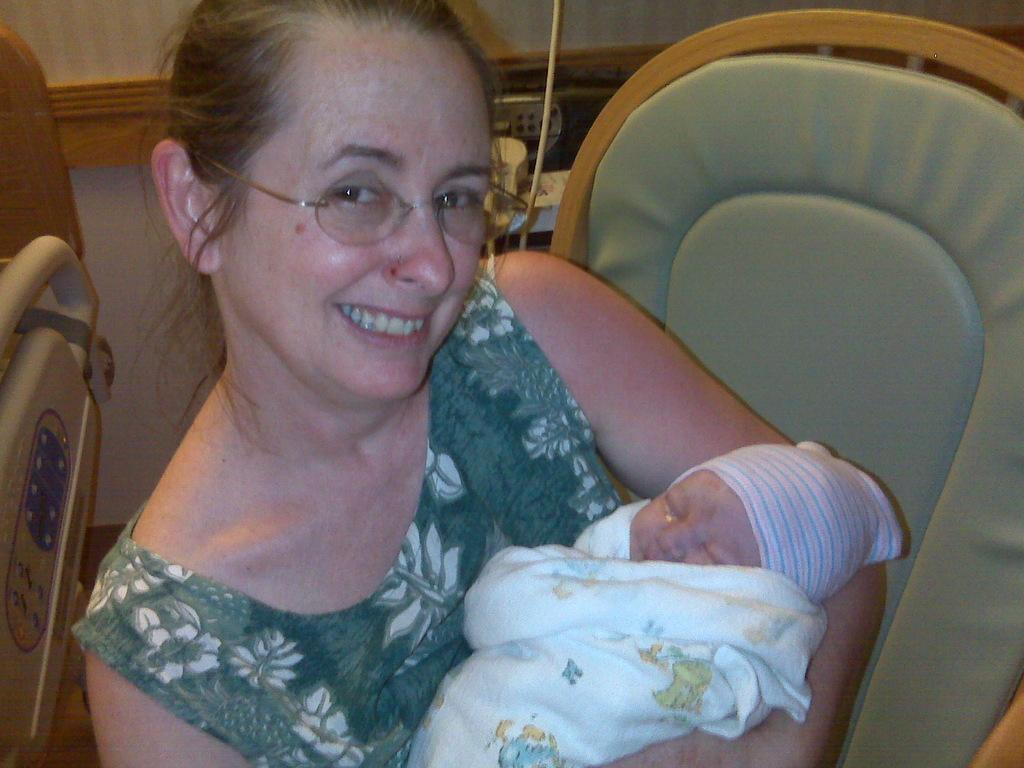Can you describe this image briefly? In this image we can see a lady sitting on the chair and holding a baby with a smile on her face, beside her there is a stretcher, behind her there are few objects. 